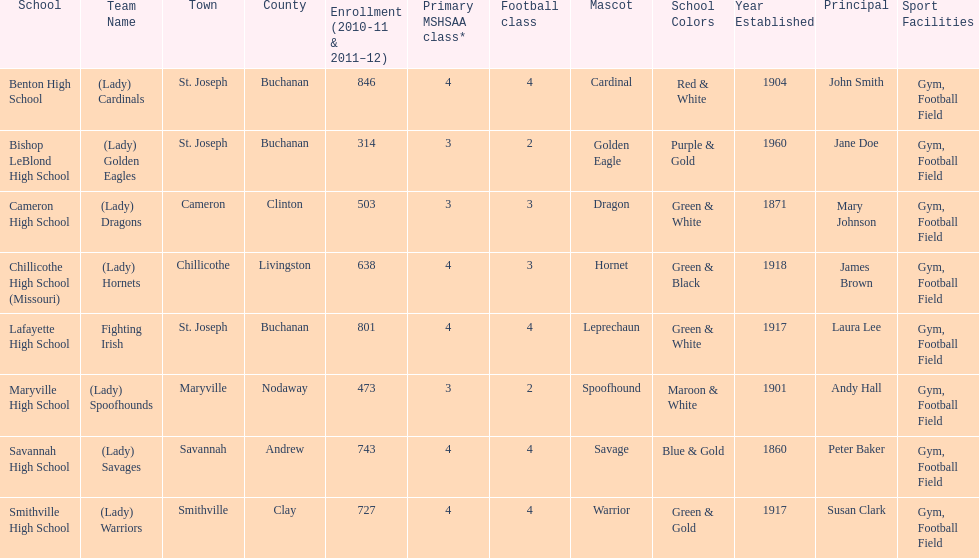What school has 3 football classes but only has 638 student enrollment? Chillicothe High School (Missouri). 